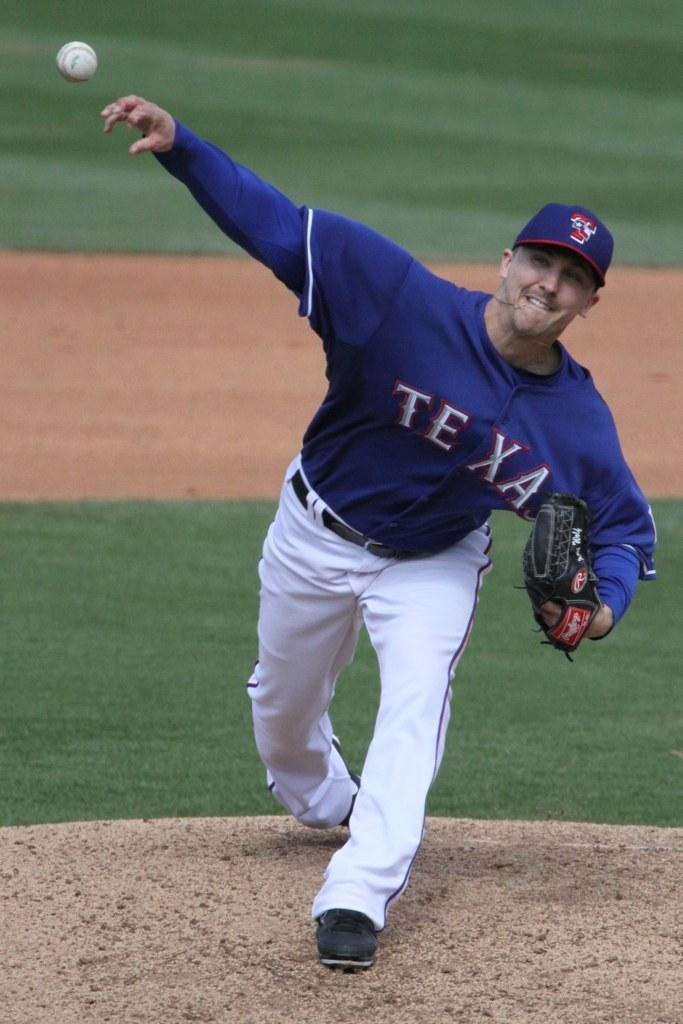<image>
Provide a brief description of the given image. Texas Rangers pitcher throwing a baseball at home plate. 